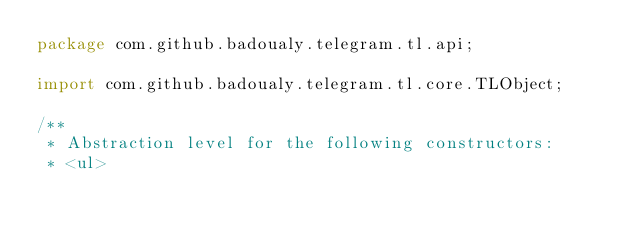<code> <loc_0><loc_0><loc_500><loc_500><_Java_>package com.github.badoualy.telegram.tl.api;

import com.github.badoualy.telegram.tl.core.TLObject;

/**
 * Abstraction level for the following constructors:
 * <ul></code> 